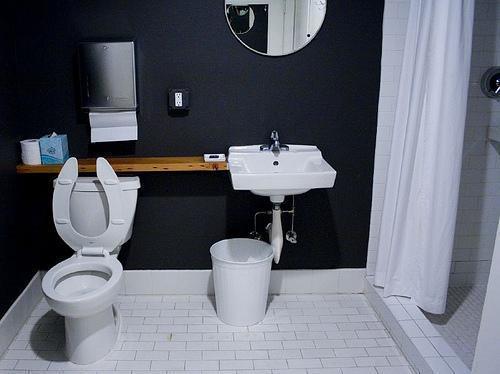How many rolls of toilet paper?
Give a very brief answer. 1. How many bears are there?
Give a very brief answer. 0. 